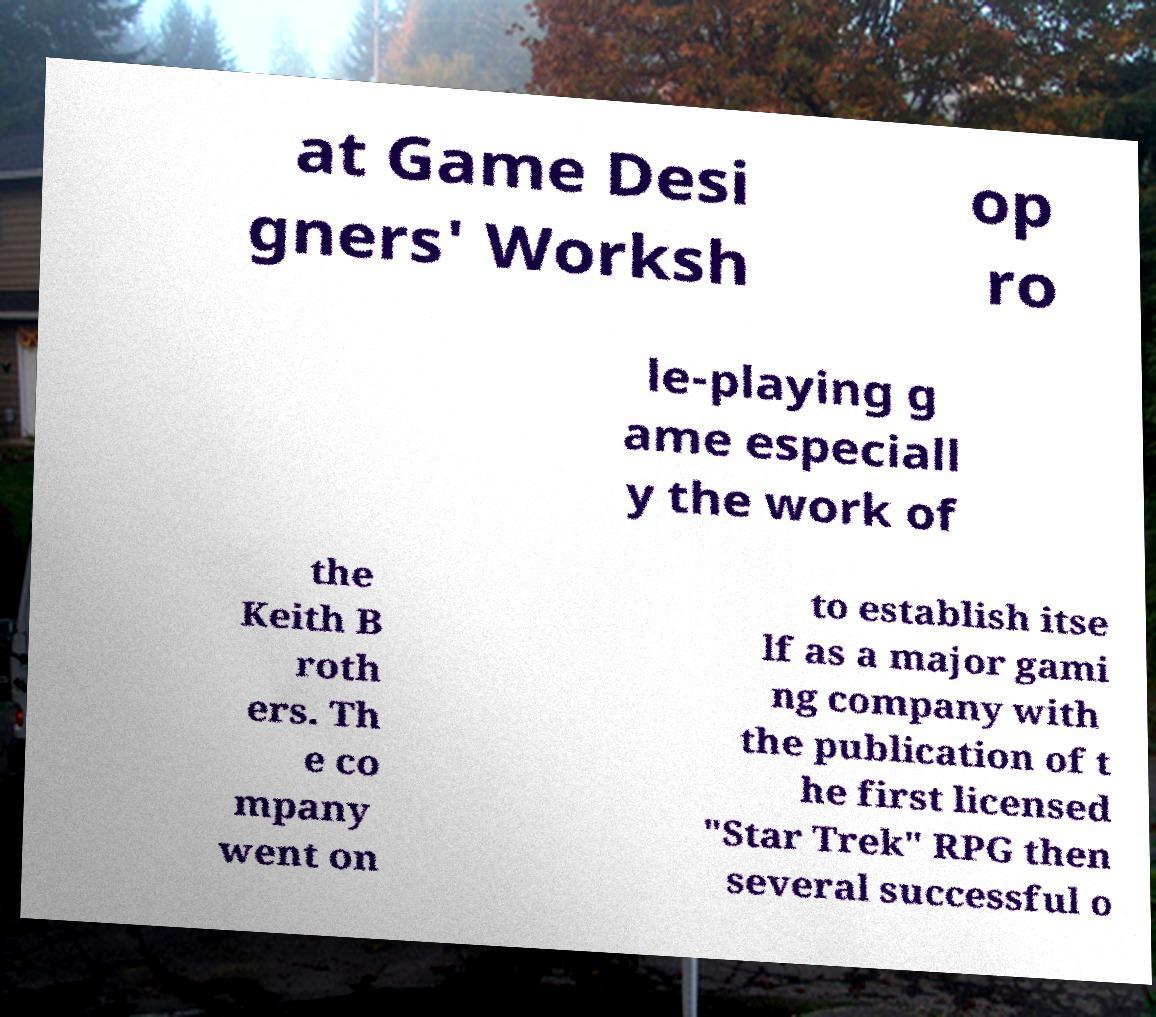There's text embedded in this image that I need extracted. Can you transcribe it verbatim? at Game Desi gners' Worksh op ro le-playing g ame especiall y the work of the Keith B roth ers. Th e co mpany went on to establish itse lf as a major gami ng company with the publication of t he first licensed "Star Trek" RPG then several successful o 